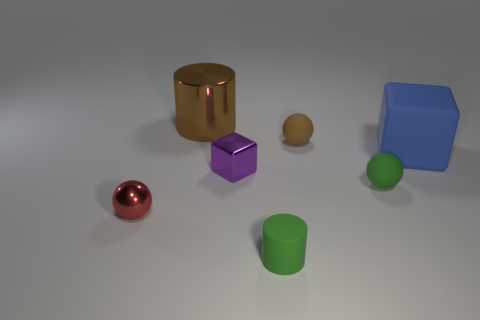Add 3 tiny blue rubber objects. How many objects exist? 10 Subtract all spheres. How many objects are left? 4 Subtract 0 blue cylinders. How many objects are left? 7 Subtract all tiny matte cylinders. Subtract all brown metal cylinders. How many objects are left? 5 Add 5 brown matte objects. How many brown matte objects are left? 6 Add 3 big brown cylinders. How many big brown cylinders exist? 4 